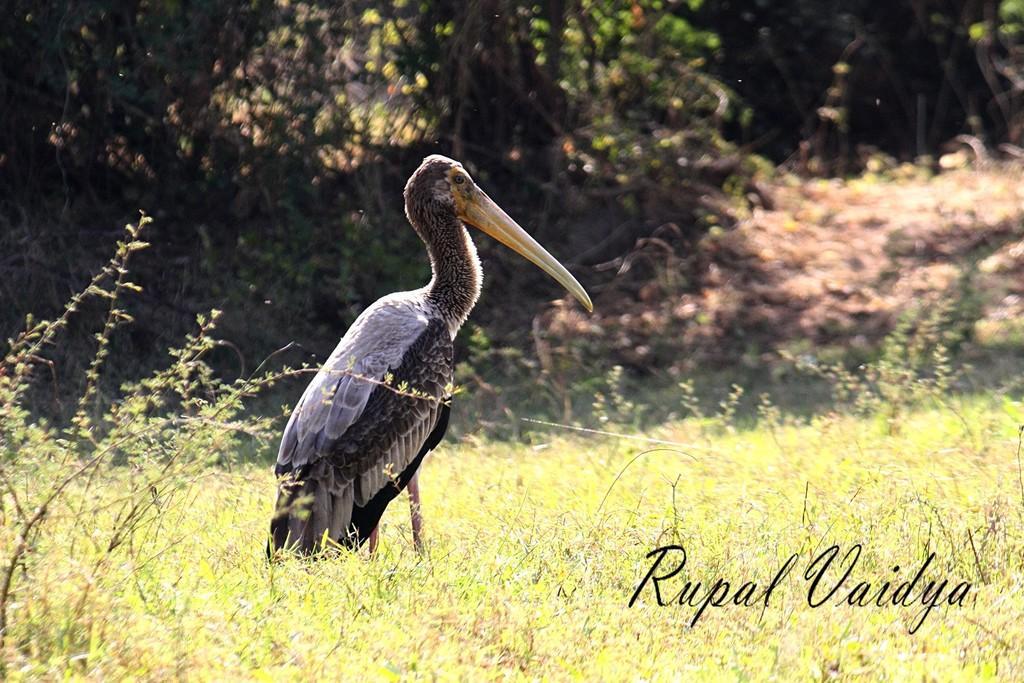Can you describe this image briefly? In this image we can see a bird. On the ground there is grass. In the background there are trees. At the bottom something is written. 